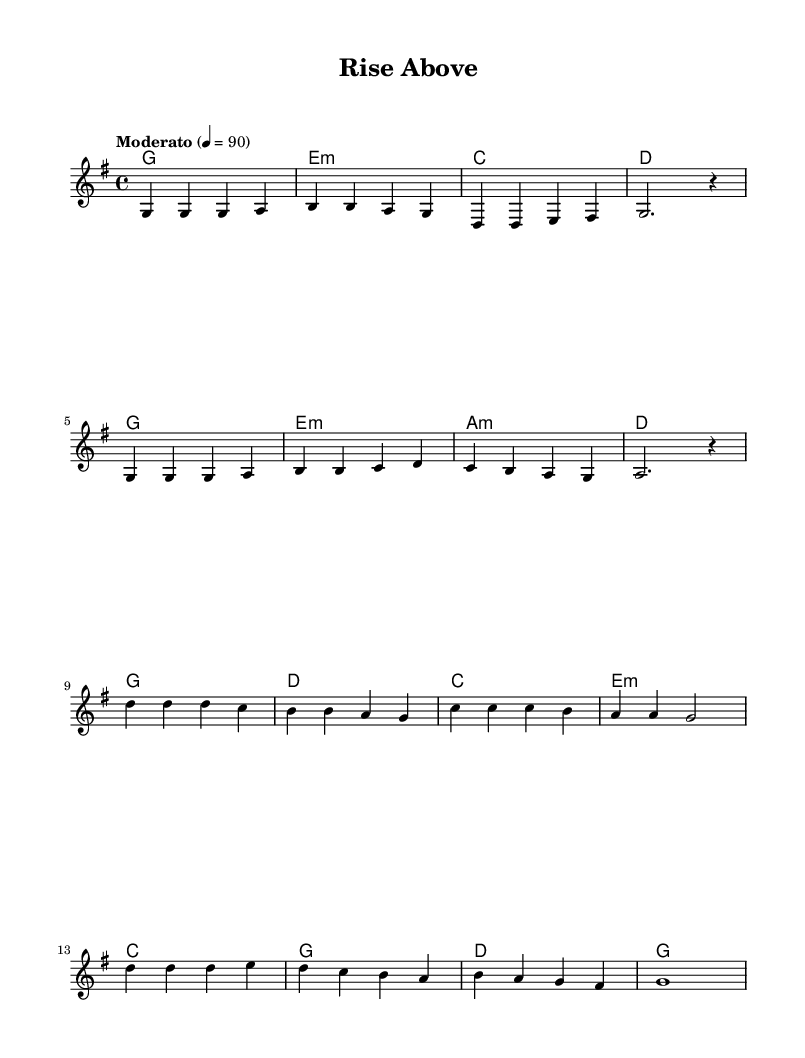What is the key signature of this music? The key signature is G major, indicated by the one sharp (F#) in the signature at the beginning of the staff.
Answer: G major What is the time signature of this music? The time signature is 4/4, shown at the beginning of the score, indicating four beats per measure with a quarter note getting one beat.
Answer: 4/4 What is the tempo marking for this piece? The tempo is marked "Moderato," which typically indicates a moderate or moderate-slow tempo. In the code, the tempo is set to 90 beats per minute, adding further clarity.
Answer: Moderato How many measures are in the verse section? The verse is composed of 8 measures as it can be counted visually and matched to the music notation provided.
Answer: 8 measures What chord follows the E minor chord in the verse? After the E minor chord, the next chord listed is A minor in the verse. This can be verified by looking at the sequence provided in the harmonies section of the score.
Answer: A minor What is the last note of the chorus section? The last note of the chorus is a G note, as indicated at the end of the chorus melody line in the notation. It is noted as a whole note tied to the bar line.
Answer: G 